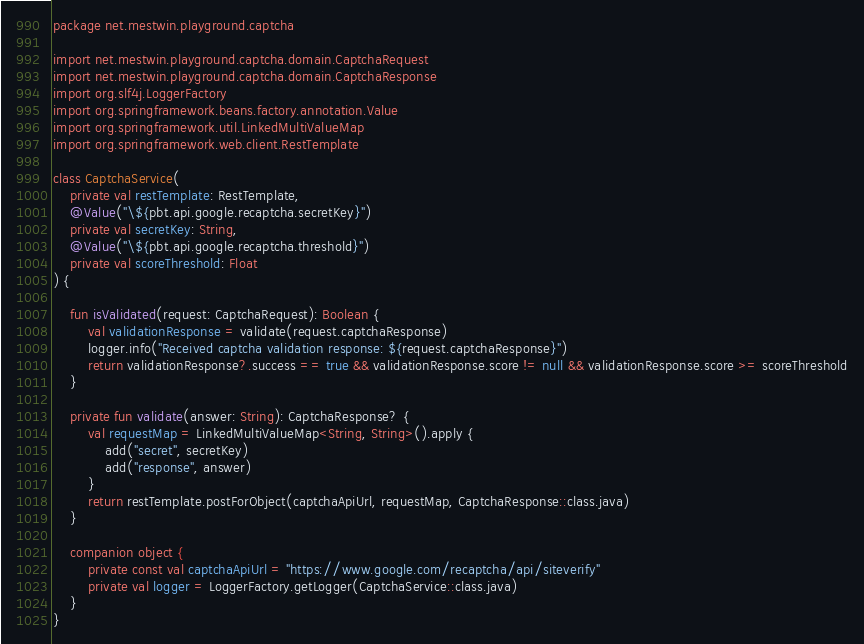<code> <loc_0><loc_0><loc_500><loc_500><_Kotlin_>package net.mestwin.playground.captcha

import net.mestwin.playground.captcha.domain.CaptchaRequest
import net.mestwin.playground.captcha.domain.CaptchaResponse
import org.slf4j.LoggerFactory
import org.springframework.beans.factory.annotation.Value
import org.springframework.util.LinkedMultiValueMap
import org.springframework.web.client.RestTemplate

class CaptchaService(
    private val restTemplate: RestTemplate,
    @Value("\${pbt.api.google.recaptcha.secretKey}")
    private val secretKey: String,
    @Value("\${pbt.api.google.recaptcha.threshold}")
    private val scoreThreshold: Float
) {

    fun isValidated(request: CaptchaRequest): Boolean {
        val validationResponse = validate(request.captchaResponse)
        logger.info("Received captcha validation response: ${request.captchaResponse}")
        return validationResponse?.success == true && validationResponse.score != null && validationResponse.score >= scoreThreshold
    }

    private fun validate(answer: String): CaptchaResponse? {
        val requestMap = LinkedMultiValueMap<String, String>().apply {
            add("secret", secretKey)
            add("response", answer)
        }
        return restTemplate.postForObject(captchaApiUrl, requestMap, CaptchaResponse::class.java)
    }

    companion object {
        private const val captchaApiUrl = "https://www.google.com/recaptcha/api/siteverify"
        private val logger = LoggerFactory.getLogger(CaptchaService::class.java)
    }
}
</code> 